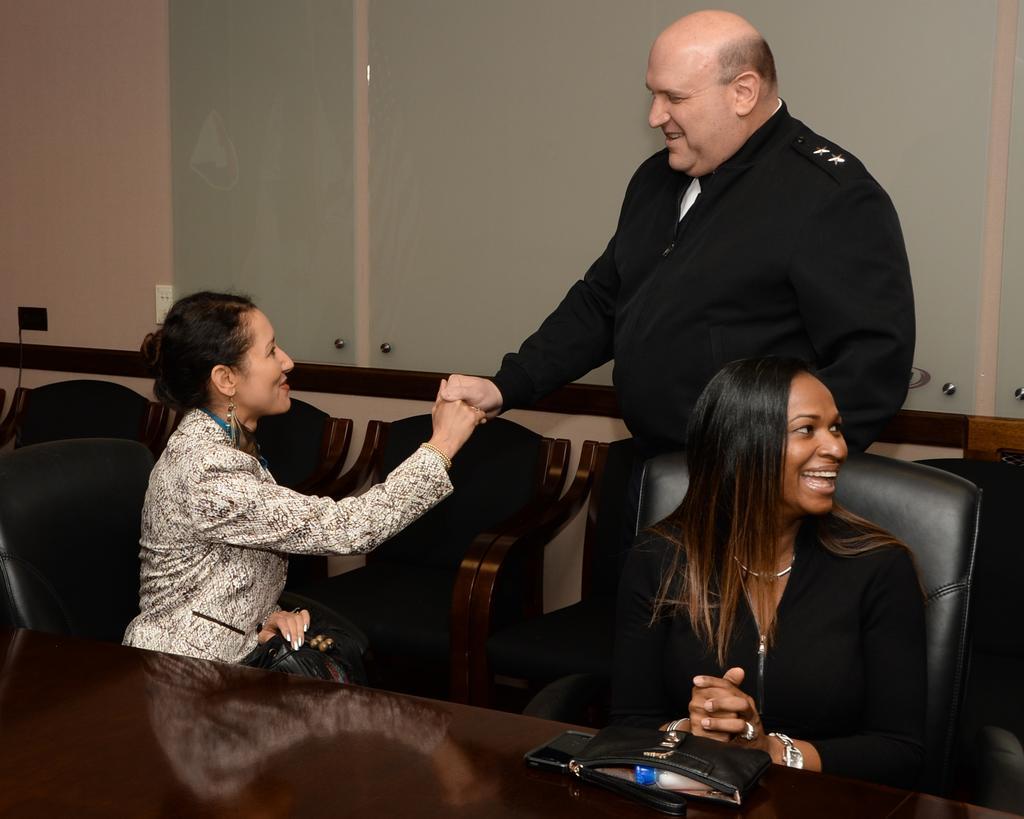How would you summarize this image in a sentence or two? In this there are two women sitting on the chair. In front of them there is a table. On top of the table there is a purse. Behind the chair there is a person standing and he was smiling. At the back side there is a wall. 